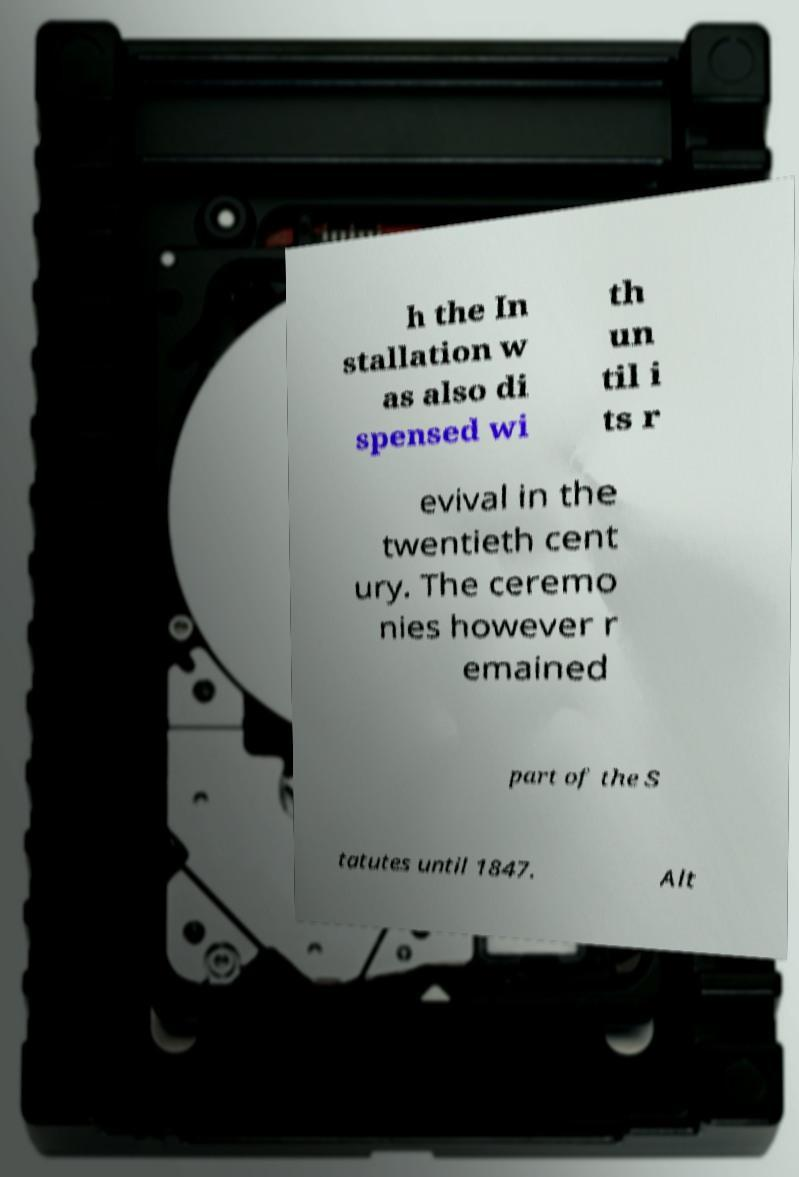Can you accurately transcribe the text from the provided image for me? h the In stallation w as also di spensed wi th un til i ts r evival in the twentieth cent ury. The ceremo nies however r emained part of the S tatutes until 1847. Alt 